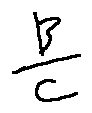<formula> <loc_0><loc_0><loc_500><loc_500>\frac { B } { c }</formula> 